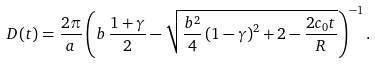Convert formula to latex. <formula><loc_0><loc_0><loc_500><loc_500>D ( t ) = \frac { 2 \pi } { a } \left ( b \, \frac { 1 + \gamma } { 2 } - \sqrt { \frac { b ^ { 2 } } { 4 } \left ( 1 - \gamma \right ) ^ { 2 } + 2 - \frac { 2 c _ { 0 } t } { R } } \right ) ^ { - 1 } .</formula> 